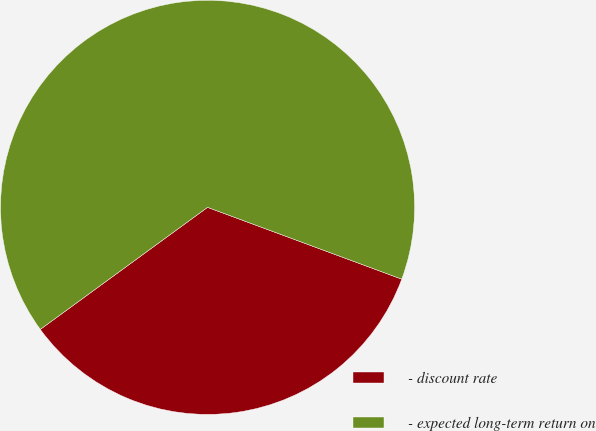Convert chart. <chart><loc_0><loc_0><loc_500><loc_500><pie_chart><fcel>- discount rate<fcel>- expected long-term return on<nl><fcel>34.33%<fcel>65.67%<nl></chart> 